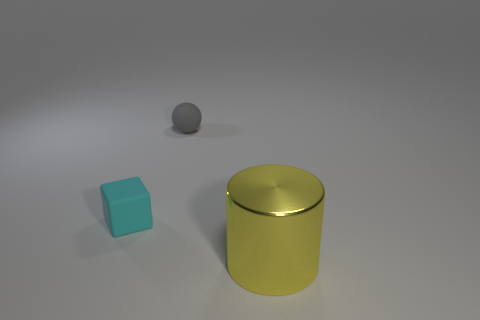There is a tiny thing on the left side of the gray object; is it the same color as the big cylinder?
Offer a terse response. No. How many things are tiny red matte spheres or objects to the left of the big yellow cylinder?
Offer a terse response. 2. Is the shape of the matte thing to the left of the tiny gray ball the same as the large yellow thing in front of the gray thing?
Your answer should be compact. No. Is there anything else that is the same color as the tiny ball?
Your answer should be very brief. No. There is a small gray thing that is made of the same material as the tiny block; what shape is it?
Your answer should be very brief. Sphere. The thing that is both in front of the small gray thing and on the right side of the cyan rubber object is made of what material?
Your answer should be compact. Metal. Is there anything else that has the same size as the gray matte thing?
Keep it short and to the point. Yes. Is the small ball the same color as the large cylinder?
Provide a short and direct response. No. How many other small gray rubber objects have the same shape as the gray object?
Make the answer very short. 0. There is a object that is made of the same material as the block; what is its size?
Keep it short and to the point. Small. 